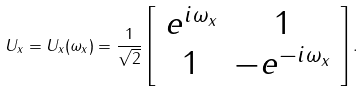<formula> <loc_0><loc_0><loc_500><loc_500>U _ { x } = U _ { x } ( \omega _ { x } ) = \frac { 1 } { \sqrt { 2 } } \left [ \begin{array} { c c } e ^ { i \omega _ { x } } & 1 \\ 1 & - e ^ { - i \omega _ { x } } \end{array} \right ] .</formula> 